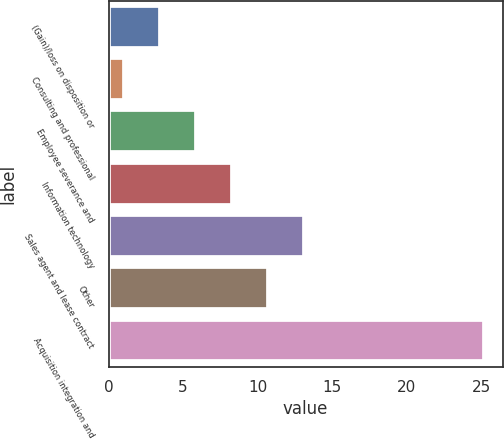Convert chart. <chart><loc_0><loc_0><loc_500><loc_500><bar_chart><fcel>(Gain)/loss on disposition or<fcel>Consulting and professional<fcel>Employee severance and<fcel>Information technology<fcel>Sales agent and lease contract<fcel>Other<fcel>Acquisition integration and<nl><fcel>3.42<fcel>1<fcel>5.84<fcel>8.26<fcel>13.1<fcel>10.68<fcel>25.2<nl></chart> 